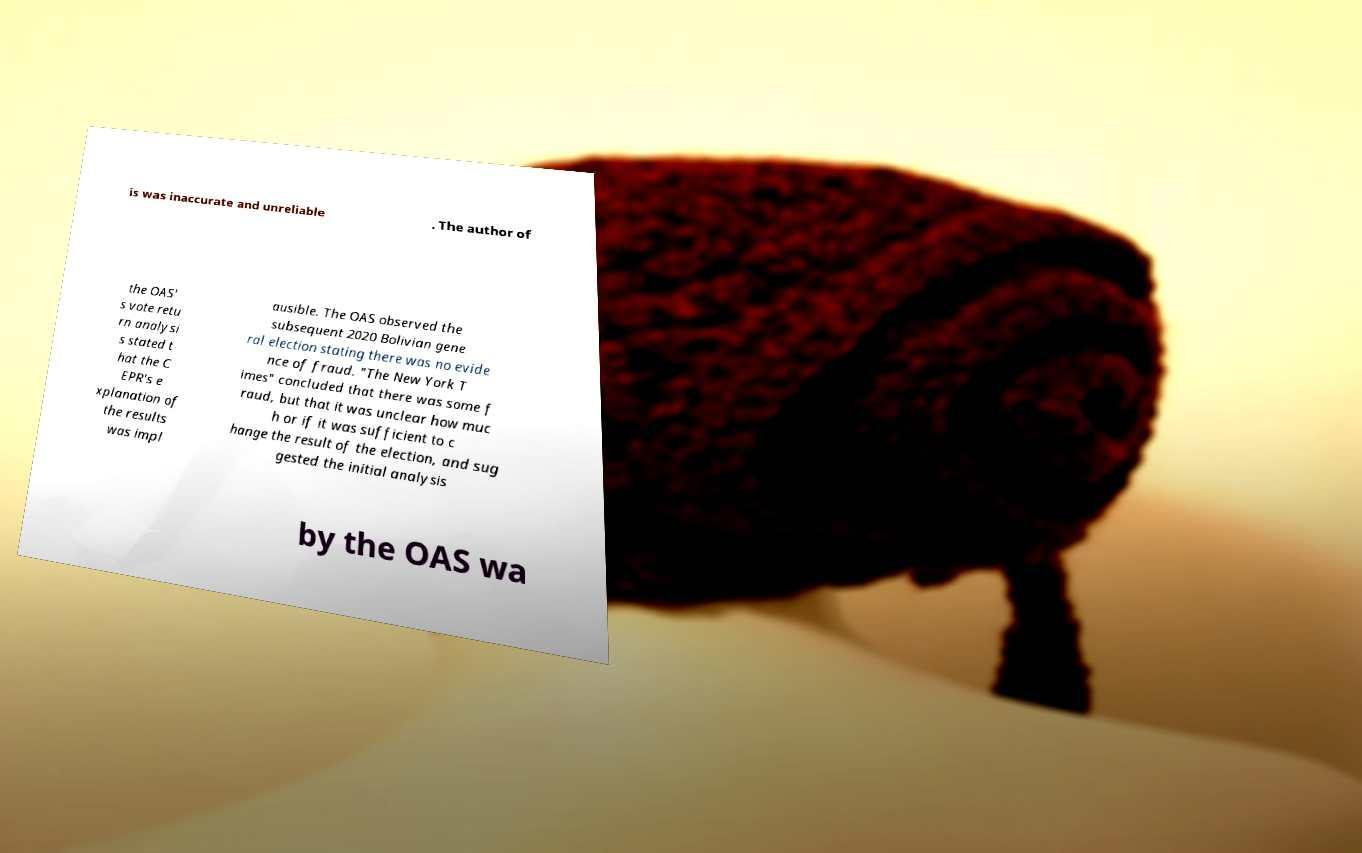Could you assist in decoding the text presented in this image and type it out clearly? is was inaccurate and unreliable . The author of the OAS' s vote retu rn analysi s stated t hat the C EPR's e xplanation of the results was impl ausible. The OAS observed the subsequent 2020 Bolivian gene ral election stating there was no evide nce of fraud. "The New York T imes" concluded that there was some f raud, but that it was unclear how muc h or if it was sufficient to c hange the result of the election, and sug gested the initial analysis by the OAS wa 